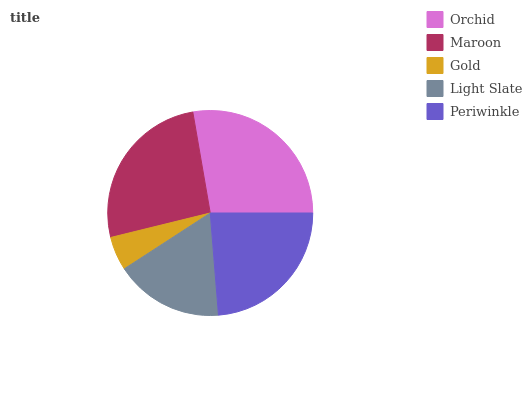Is Gold the minimum?
Answer yes or no. Yes. Is Orchid the maximum?
Answer yes or no. Yes. Is Maroon the minimum?
Answer yes or no. No. Is Maroon the maximum?
Answer yes or no. No. Is Orchid greater than Maroon?
Answer yes or no. Yes. Is Maroon less than Orchid?
Answer yes or no. Yes. Is Maroon greater than Orchid?
Answer yes or no. No. Is Orchid less than Maroon?
Answer yes or no. No. Is Periwinkle the high median?
Answer yes or no. Yes. Is Periwinkle the low median?
Answer yes or no. Yes. Is Gold the high median?
Answer yes or no. No. Is Orchid the low median?
Answer yes or no. No. 